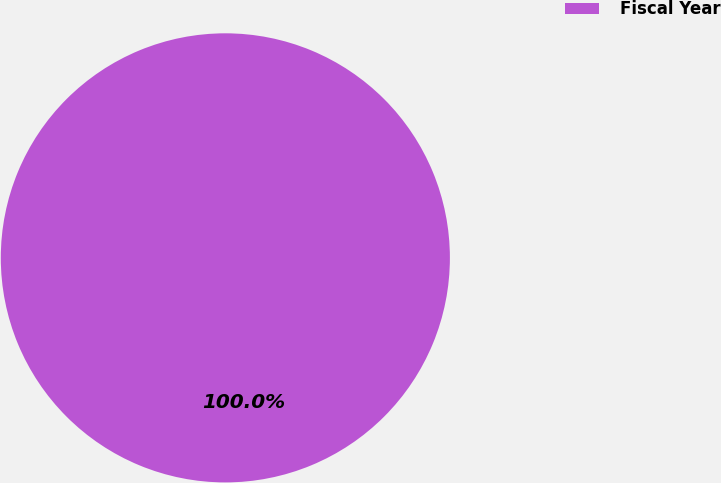Convert chart. <chart><loc_0><loc_0><loc_500><loc_500><pie_chart><fcel>Fiscal Year<nl><fcel>100.0%<nl></chart> 